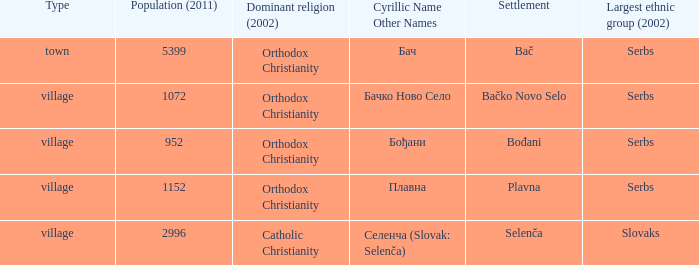What is the smallest population listed? 952.0. 